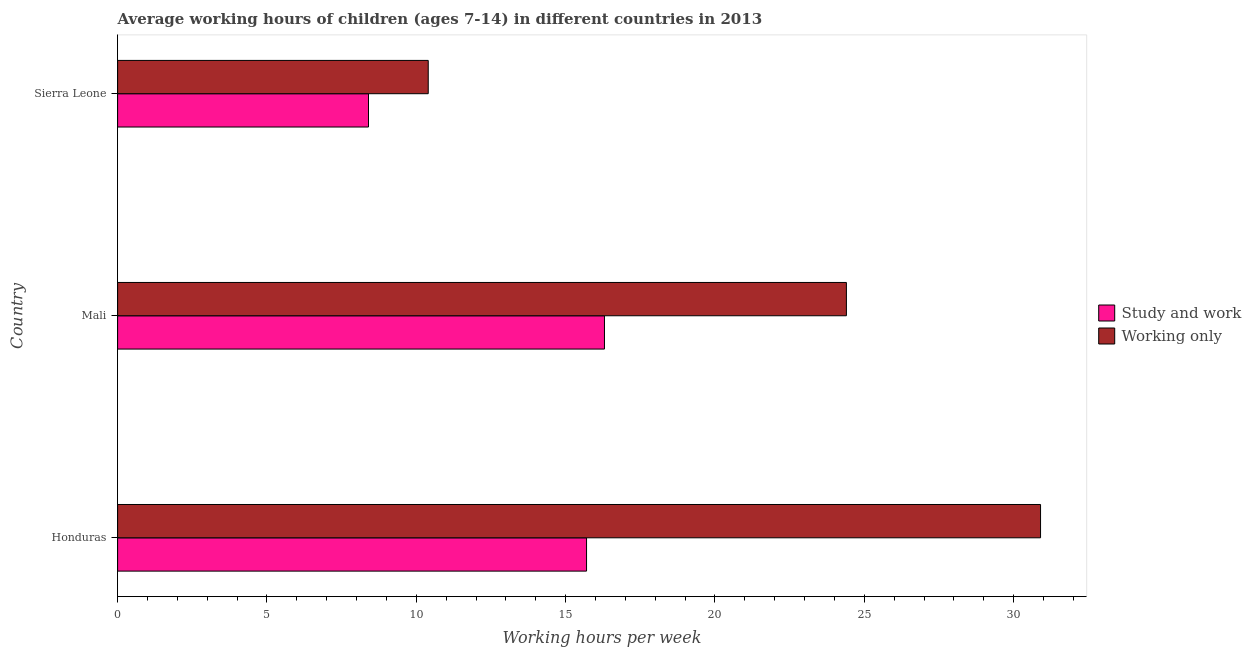How many different coloured bars are there?
Give a very brief answer. 2. How many groups of bars are there?
Offer a very short reply. 3. Are the number of bars per tick equal to the number of legend labels?
Provide a succinct answer. Yes. Are the number of bars on each tick of the Y-axis equal?
Make the answer very short. Yes. How many bars are there on the 2nd tick from the bottom?
Provide a short and direct response. 2. What is the label of the 3rd group of bars from the top?
Give a very brief answer. Honduras. What is the average working hour of children involved in only work in Honduras?
Your response must be concise. 30.9. In which country was the average working hour of children involved in study and work maximum?
Provide a short and direct response. Mali. In which country was the average working hour of children involved in study and work minimum?
Your response must be concise. Sierra Leone. What is the total average working hour of children involved in study and work in the graph?
Your answer should be very brief. 40.4. What is the difference between the average working hour of children involved in study and work in Honduras and that in Mali?
Your answer should be very brief. -0.6. What is the difference between the average working hour of children involved in study and work in Honduras and the average working hour of children involved in only work in Sierra Leone?
Keep it short and to the point. 5.3. What is the average average working hour of children involved in only work per country?
Your answer should be very brief. 21.9. What is the difference between the average working hour of children involved in study and work and average working hour of children involved in only work in Honduras?
Your answer should be very brief. -15.2. In how many countries, is the average working hour of children involved in only work greater than 25 hours?
Your response must be concise. 1. What is the ratio of the average working hour of children involved in study and work in Mali to that in Sierra Leone?
Keep it short and to the point. 1.94. Is the average working hour of children involved in only work in Honduras less than that in Mali?
Make the answer very short. No. What is the difference between the highest and the second highest average working hour of children involved in study and work?
Offer a very short reply. 0.6. What is the difference between the highest and the lowest average working hour of children involved in only work?
Provide a succinct answer. 20.5. In how many countries, is the average working hour of children involved in only work greater than the average average working hour of children involved in only work taken over all countries?
Provide a short and direct response. 2. What does the 2nd bar from the top in Sierra Leone represents?
Your answer should be very brief. Study and work. What does the 2nd bar from the bottom in Sierra Leone represents?
Provide a succinct answer. Working only. Are the values on the major ticks of X-axis written in scientific E-notation?
Your answer should be compact. No. Does the graph contain grids?
Provide a succinct answer. No. Where does the legend appear in the graph?
Your response must be concise. Center right. How many legend labels are there?
Offer a very short reply. 2. How are the legend labels stacked?
Offer a very short reply. Vertical. What is the title of the graph?
Your answer should be very brief. Average working hours of children (ages 7-14) in different countries in 2013. What is the label or title of the X-axis?
Your answer should be compact. Working hours per week. What is the label or title of the Y-axis?
Provide a short and direct response. Country. What is the Working hours per week in Study and work in Honduras?
Offer a terse response. 15.7. What is the Working hours per week in Working only in Honduras?
Give a very brief answer. 30.9. What is the Working hours per week in Study and work in Mali?
Provide a short and direct response. 16.3. What is the Working hours per week in Working only in Mali?
Offer a very short reply. 24.4. What is the Working hours per week of Working only in Sierra Leone?
Provide a short and direct response. 10.4. Across all countries, what is the maximum Working hours per week in Study and work?
Your answer should be very brief. 16.3. Across all countries, what is the maximum Working hours per week of Working only?
Provide a short and direct response. 30.9. Across all countries, what is the minimum Working hours per week in Study and work?
Your answer should be very brief. 8.4. Across all countries, what is the minimum Working hours per week in Working only?
Ensure brevity in your answer.  10.4. What is the total Working hours per week in Study and work in the graph?
Make the answer very short. 40.4. What is the total Working hours per week of Working only in the graph?
Your response must be concise. 65.7. What is the difference between the Working hours per week of Study and work in Honduras and that in Sierra Leone?
Give a very brief answer. 7.3. What is the difference between the Working hours per week in Study and work in Mali and that in Sierra Leone?
Keep it short and to the point. 7.9. What is the difference between the Working hours per week of Study and work in Honduras and the Working hours per week of Working only in Mali?
Make the answer very short. -8.7. What is the average Working hours per week of Study and work per country?
Make the answer very short. 13.47. What is the average Working hours per week in Working only per country?
Give a very brief answer. 21.9. What is the difference between the Working hours per week of Study and work and Working hours per week of Working only in Honduras?
Provide a succinct answer. -15.2. What is the difference between the Working hours per week of Study and work and Working hours per week of Working only in Mali?
Keep it short and to the point. -8.1. What is the difference between the Working hours per week in Study and work and Working hours per week in Working only in Sierra Leone?
Provide a succinct answer. -2. What is the ratio of the Working hours per week in Study and work in Honduras to that in Mali?
Make the answer very short. 0.96. What is the ratio of the Working hours per week in Working only in Honduras to that in Mali?
Provide a succinct answer. 1.27. What is the ratio of the Working hours per week in Study and work in Honduras to that in Sierra Leone?
Provide a succinct answer. 1.87. What is the ratio of the Working hours per week in Working only in Honduras to that in Sierra Leone?
Offer a very short reply. 2.97. What is the ratio of the Working hours per week in Study and work in Mali to that in Sierra Leone?
Ensure brevity in your answer.  1.94. What is the ratio of the Working hours per week in Working only in Mali to that in Sierra Leone?
Provide a short and direct response. 2.35. What is the difference between the highest and the second highest Working hours per week of Working only?
Provide a short and direct response. 6.5. What is the difference between the highest and the lowest Working hours per week in Study and work?
Your answer should be very brief. 7.9. 